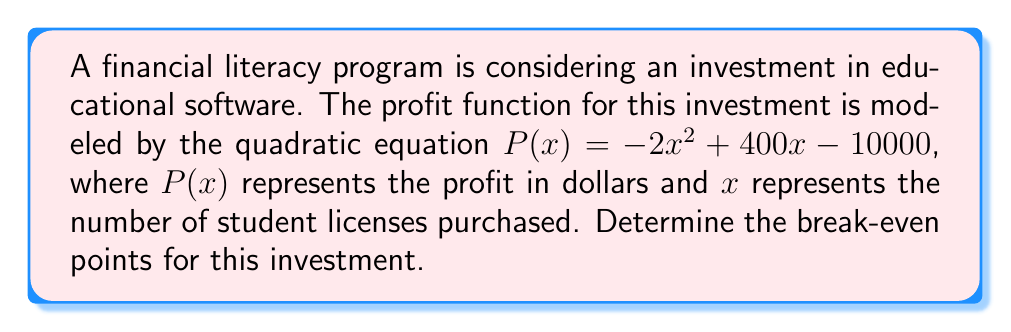Provide a solution to this math problem. To find the break-even points, we need to solve the equation $P(x) = 0$, as this represents the point where there is neither profit nor loss.

1) Set up the equation:
   $-2x^2 + 400x - 10000 = 0$

2) This is a quadratic equation in the standard form $ax^2 + bx + c = 0$, where:
   $a = -2$, $b = 400$, and $c = -10000$

3) We can solve this using the quadratic formula: $x = \frac{-b \pm \sqrt{b^2 - 4ac}}{2a}$

4) Substituting the values:
   $x = \frac{-400 \pm \sqrt{400^2 - 4(-2)(-10000)}}{2(-2)}$

5) Simplify:
   $x = \frac{-400 \pm \sqrt{160000 - 80000}}{-4}$
   $x = \frac{-400 \pm \sqrt{80000}}{-4}$
   $x = \frac{-400 \pm 282.84}{-4}$

6) Solve for both possibilities:
   $x_1 = \frac{-400 + 282.84}{-4} = 29.29$
   $x_2 = \frac{-400 - 282.84}{-4} = 170.71$

7) Round to the nearest whole number, as we can't sell partial licenses:
   $x_1 \approx 29$ licenses
   $x_2 \approx 171$ licenses
Answer: The break-even points occur when approximately 29 licenses or 171 licenses are sold. 